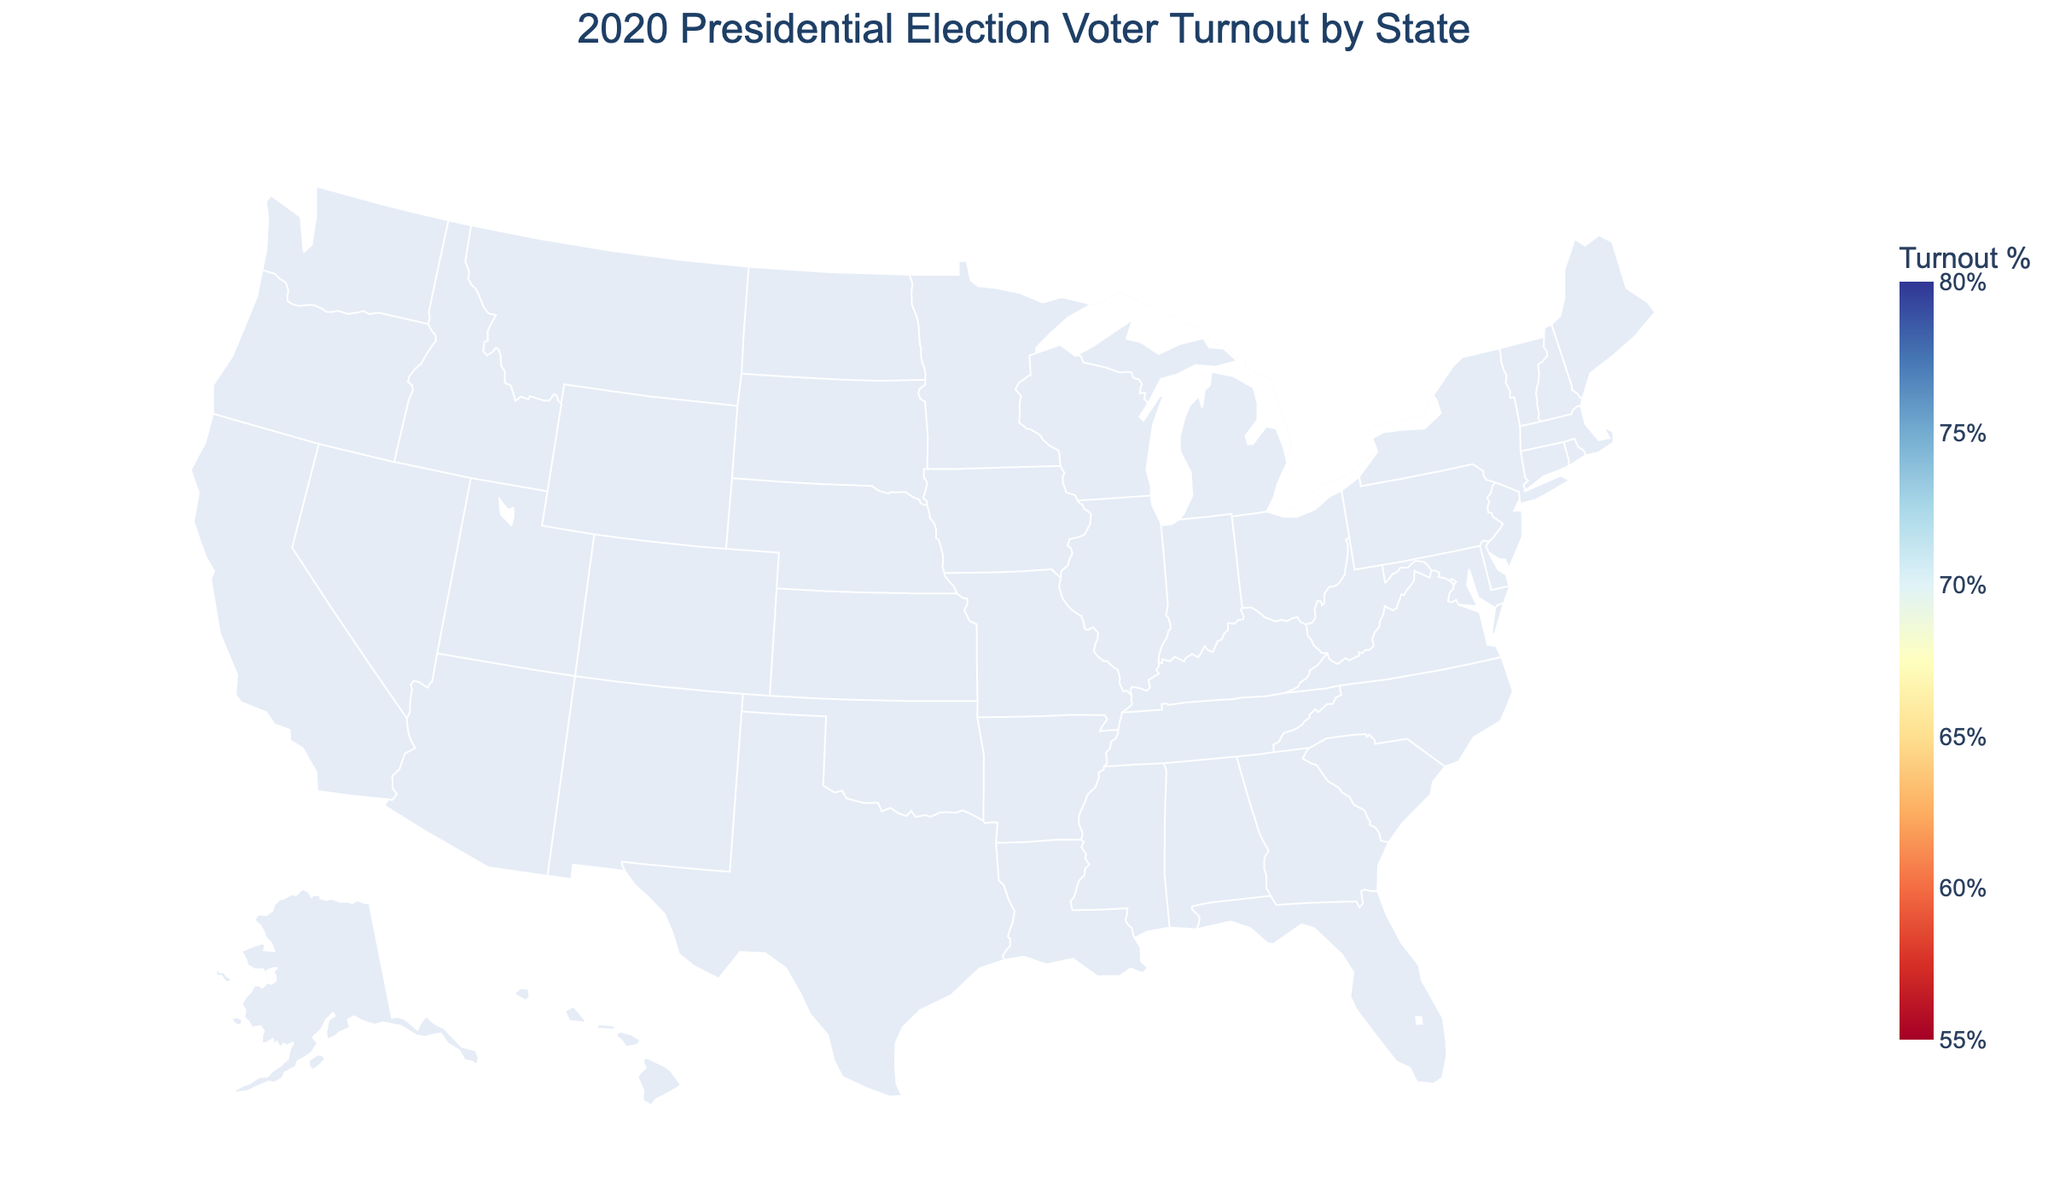What's the highest voter turnout percentage among the U.S. states? The highest percentage corresponds to Minnesota. By observing the shade of color and any included text annotations on the choropleth map, Minnesota stands out with the lightest shade of blue and is annotated with a turnout percentage of 79.96%.
Answer: 79.96% Which state had the lowest voter turnout percentage, and what was it? By examining the color gradient and text annotations on the map, Hawaii stands out with the darkest shade of blue and is annotated with a turnout percentage of 57.53%.
Answer: Hawaii, 57.53% What is the overall title of the map? The map's title is explicitly written at the top of the choropleth map, displaying the overall subject of the visualization.
Answer: 2020 Presidential Election Voter Turnout by State Which states had a voter turnout percentage above 70% but below 75%? By carefully inspecting the textual annotations and the color gradient on the map, we identify several states that fall within this range: Michigan (74.01%), Virginia (73.34%), Florida (71.67%), North Carolina (71.46%), and Pennsylvania (70.63%).
Answer: Michigan, Virginia, Florida, North Carolina, Pennsylvania How does Texas compare to New York in terms of voter turnout percentage? Referring to the text annotations and color shades for each state on the map, Texas has a turnout of 60.43% and New York has a turnout of 63.41%. Therefore, New York has a slightly higher voter turnout than Texas.
Answer: New York has a higher turnout What is the color scale used to represent the voter turnout percentages? By examining the legend or color bar on the side of the map, we see that a continuous color gradient from red to yellow to blue (RdYlBu) is used, representing the range of turnout percentages from 55% to 80%.
Answer: RdYlBu What's the difference in voter turnout between the state with the highest turnout and the state with the lowest turnout? Observing the annotations on the map, the highest turnout is 79.96% (Minnesota) and the lowest is 57.53% (Hawaii). Subtracting these values gives 79.96% - 57.53% = 22.43%.
Answer: 22.43% Are there any regional patterns visible in the voter turnout data? By observing clusters of similar colors on the map, we can identify regional patterns. States in the northern U.S. (e.g., Minnesota, Maine, Wisconsin) generally have high turnout rates, whereas some southern states (e.g., Texas, Mississippi, Alabama) have relatively lower turnout rates.
Answer: Northern states have higher turnout; southern states have lower turnout 